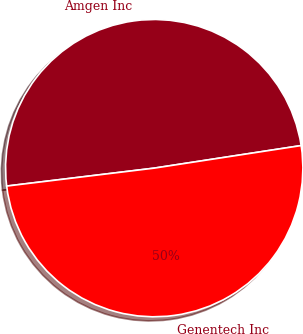Convert chart. <chart><loc_0><loc_0><loc_500><loc_500><pie_chart><fcel>Amgen Inc<fcel>Genentech Inc<nl><fcel>49.5%<fcel>50.5%<nl></chart> 